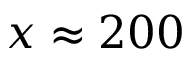<formula> <loc_0><loc_0><loc_500><loc_500>x \approx 2 0 0</formula> 